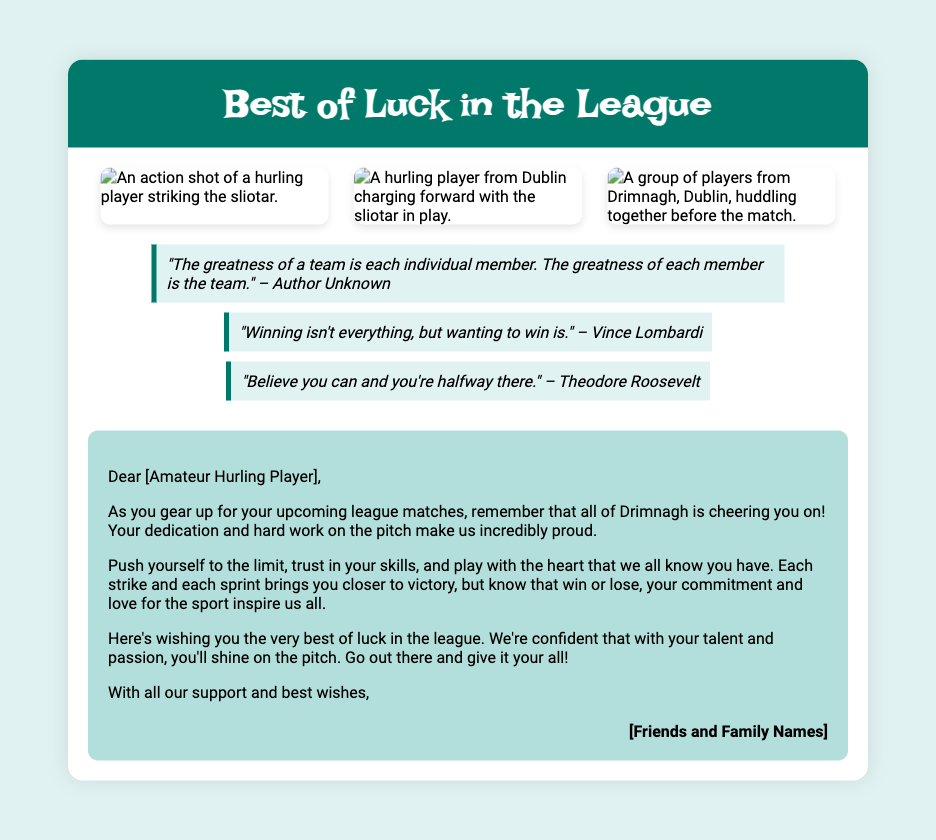What is the title of the card? The title of the card is prominently displayed at the top in a large font.
Answer: Best of Luck in the League How many action shots are included in the card? There are three images of action shots shown in the images section.
Answer: Three Who is quoted saying, "Winning isn't everything, but wanting to win is."? The quote attribution refers to a well-known football coach.
Answer: Vince Lombardi What is the main message conveyed to the amateur hurling player? The message encourages the player to perform well and reassures them of support regardless of the outcome.
Answer: Best of luck in the league Which Dublin club's players are highlighted in the images? The images showcase a huddle of players from a specific area in Dublin.
Answer: Drimnagh What color is the header background of the card? The header has a distinctive color that matches the theme of the card.
Answer: Dark green How are the inspirational quotes formatted in the card? The quotes have a specific background and border design that visually distinguishes them from other text.
Answer: Italicized with a border What is the tone of the message from friends and family? The tone is supportive and motivational, aimed at encouraging the amateur player.
Answer: Encouraging Who are the signatories of the message? The names of the individuals giving the message are represented in a specific format.
Answer: Friends and Family Names 